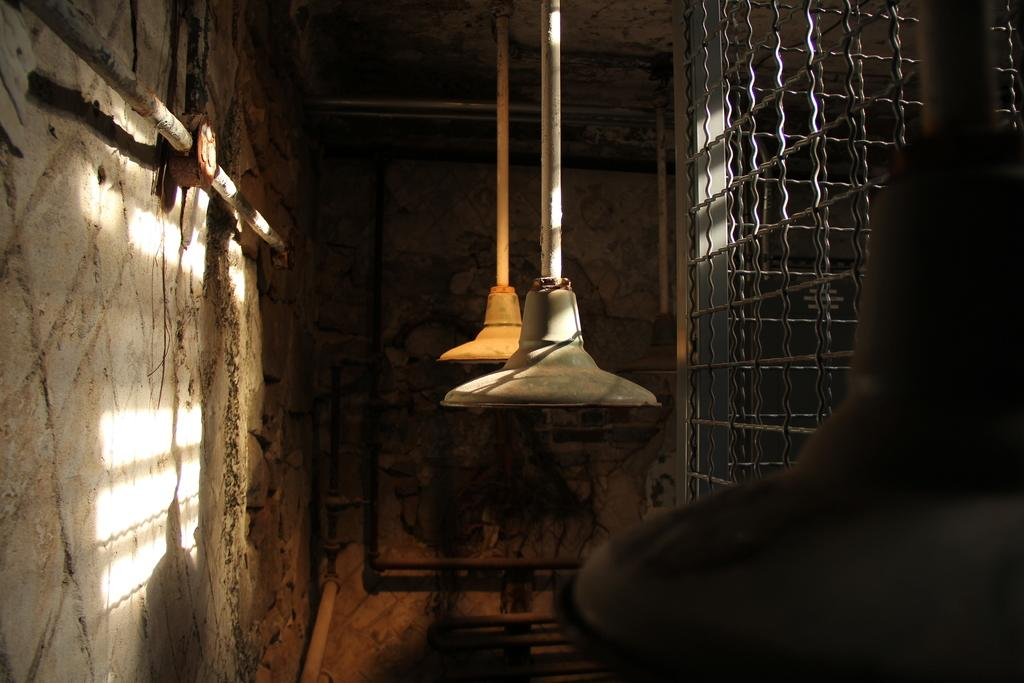What type of lighting is present in the image? There are two pendant lights in the image. What architectural feature can be seen in the image? There is railing in the image. What other objects are present in the image? There are poles in the image. What color is the wall in the image? The wall in the image is brown. What type of story is being told by the beast in the image? There is no beast present in the image, so no story is being told. Who is the achiever in the image? There is no specific person or achiever mentioned in the image. 